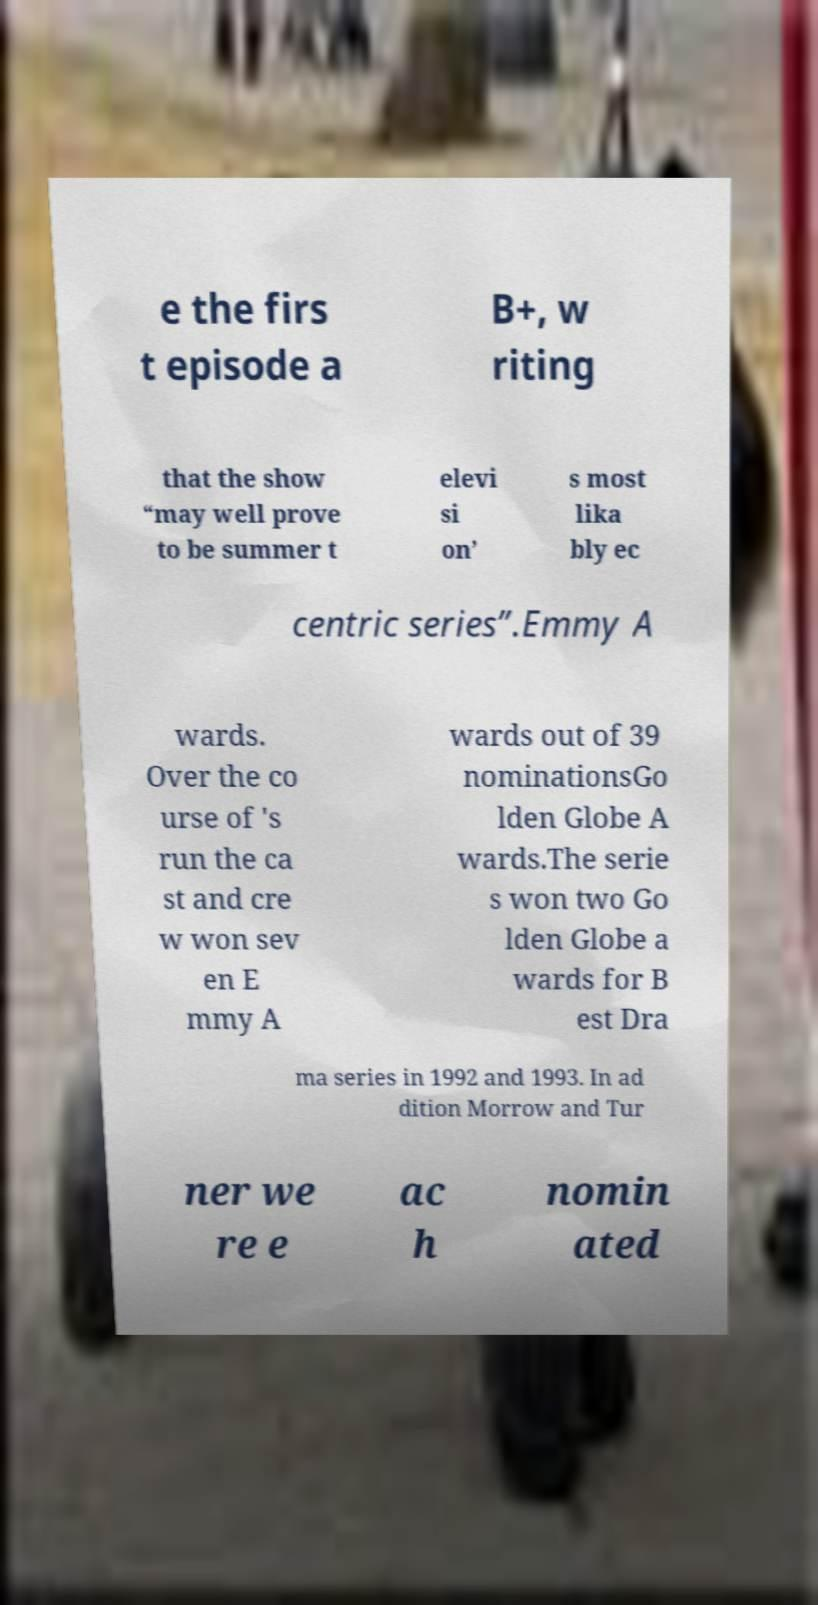For documentation purposes, I need the text within this image transcribed. Could you provide that? e the firs t episode a B+, w riting that the show “may well prove to be summer t elevi si on’ s most lika bly ec centric series”.Emmy A wards. Over the co urse of 's run the ca st and cre w won sev en E mmy A wards out of 39 nominationsGo lden Globe A wards.The serie s won two Go lden Globe a wards for B est Dra ma series in 1992 and 1993. In ad dition Morrow and Tur ner we re e ac h nomin ated 